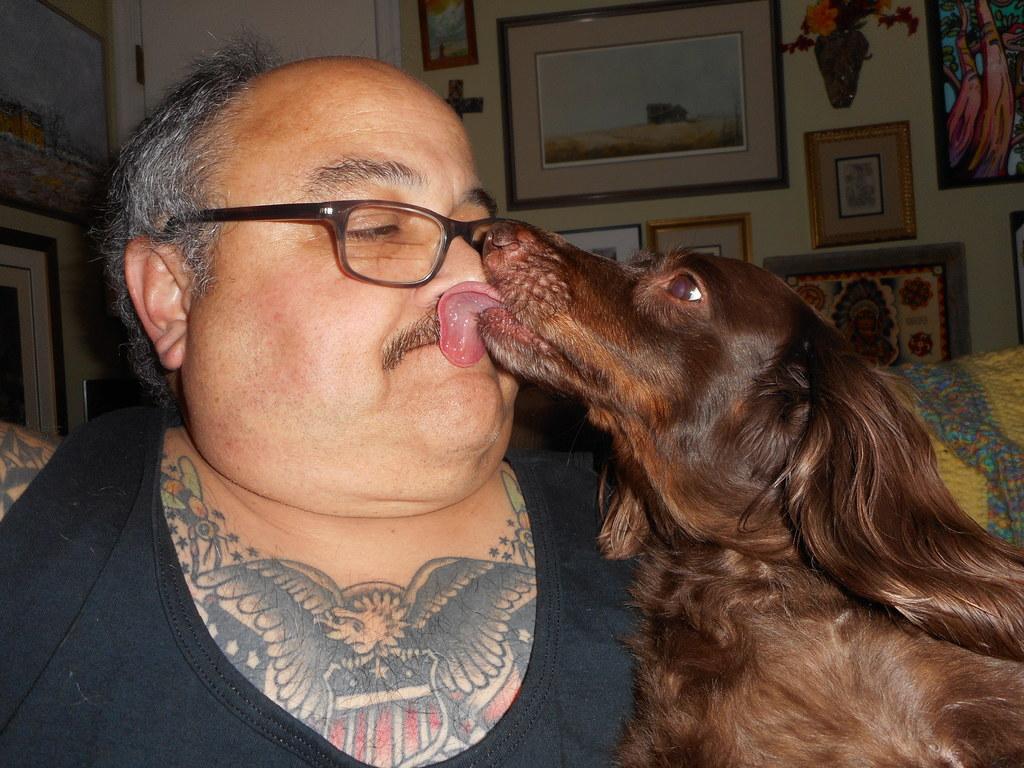How would you summarize this image in a sentence or two? Here we can see a man on the left side and a dog on the right side. In the background we can see a photo frames which are fixed to a wall. 